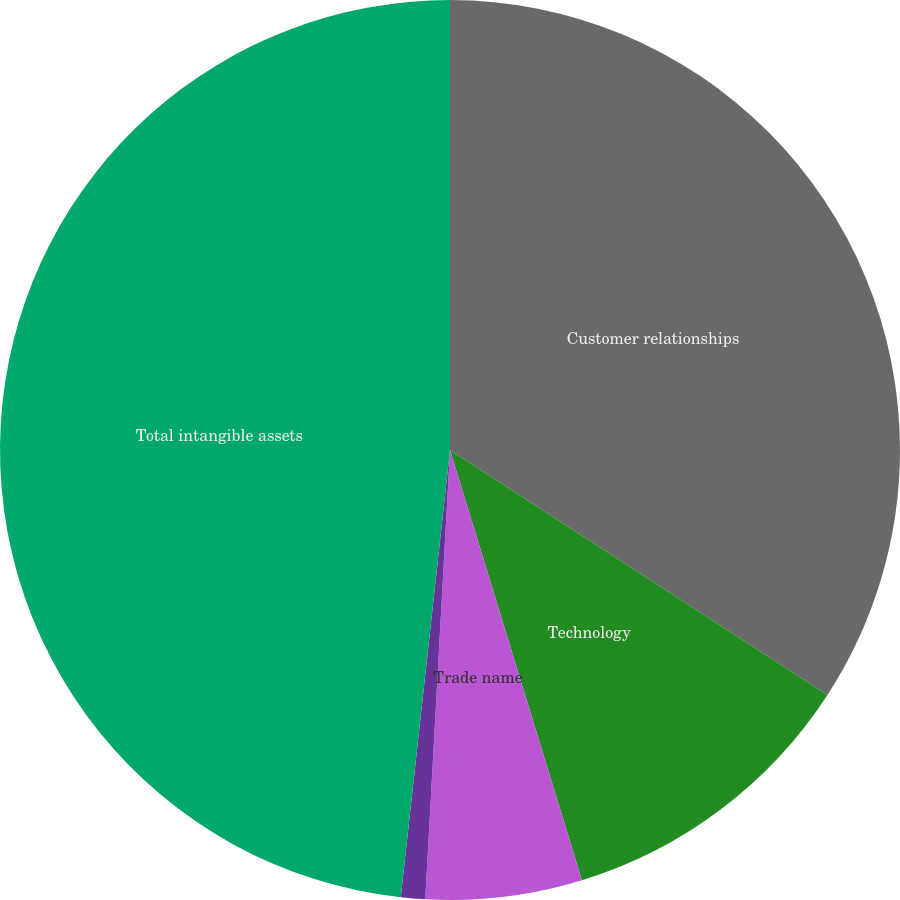Convert chart. <chart><loc_0><loc_0><loc_500><loc_500><pie_chart><fcel>Customer relationships<fcel>Technology<fcel>Trade name<fcel>Other<fcel>Total intangible assets<nl><fcel>34.16%<fcel>11.1%<fcel>5.61%<fcel>0.87%<fcel>48.25%<nl></chart> 